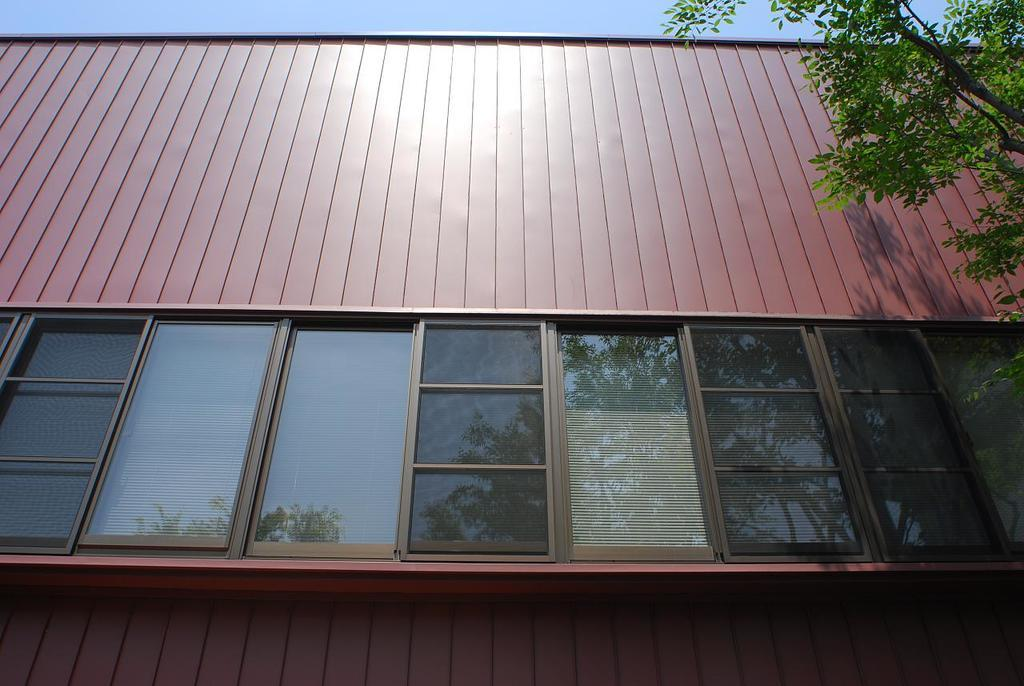Where was the picture taken? The picture was clicked outside. What can be seen in the center of the image? There are windows and a roof of a house in the center of the image. What is located in the right corner of the image? There is a tree in the right corner of the image. What is visible in the background of the image? The sky is visible in the background of the image. What type of knowledge is being shared in the image? There is no knowledge being shared in the image; it is a picture of a house, a tree, and the sky. Is there a water source visible in the image? There is no water source visible in the image. 